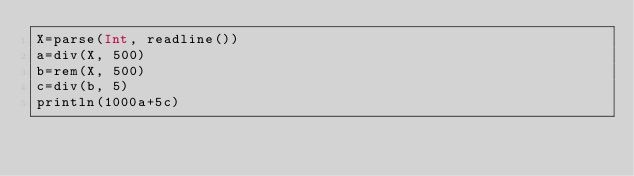Convert code to text. <code><loc_0><loc_0><loc_500><loc_500><_Julia_>X=parse(Int, readline())
a=div(X, 500)
b=rem(X, 500)
c=div(b, 5)
println(1000a+5c)</code> 